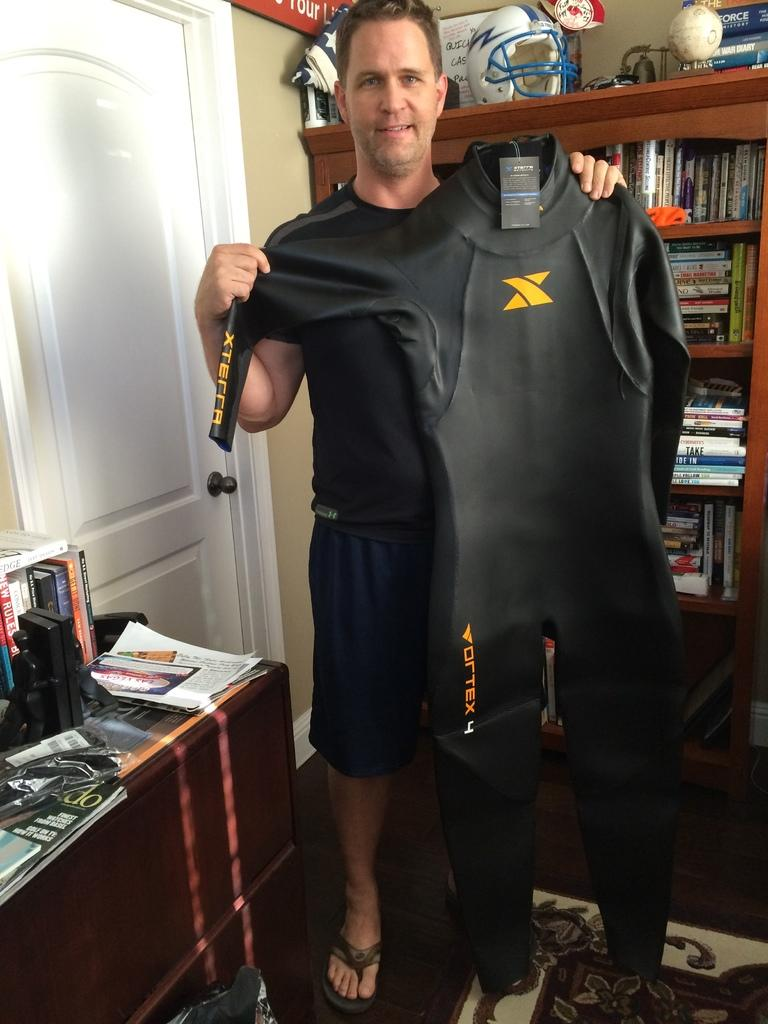Provide a one-sentence caption for the provided image. A man holding a diving suit that has Vortex 4 written on it. 